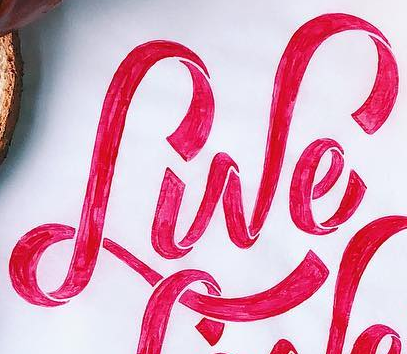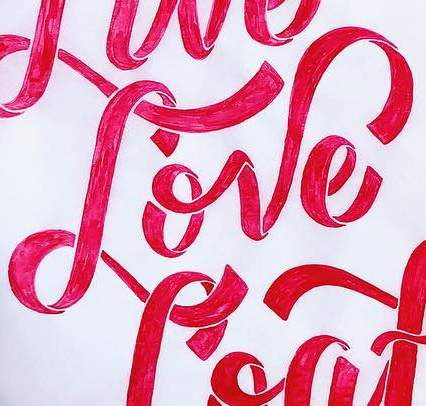What text is displayed in these images sequentially, separated by a semicolon? Lwe; Love 